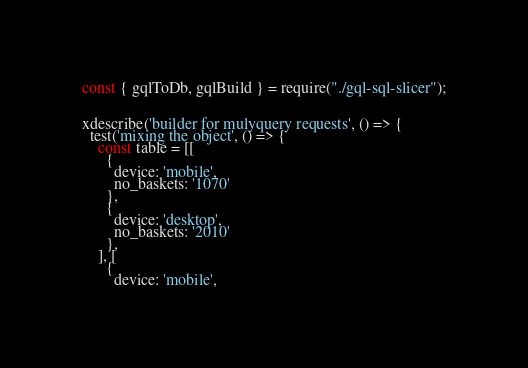<code> <loc_0><loc_0><loc_500><loc_500><_TypeScript_>const { gqlToDb, gqlBuild } = require("./gql-sql-slicer");


xdescribe('builder for mulyquery requests', () => {
  test('mixing the object', () => {
    const table = [[
      {
        device: 'mobile',
        no_baskets: '1070'
      },
      {
        device: 'desktop',
        no_baskets: '2010'
      },
    ], [
      {
        device: 'mobile',</code> 